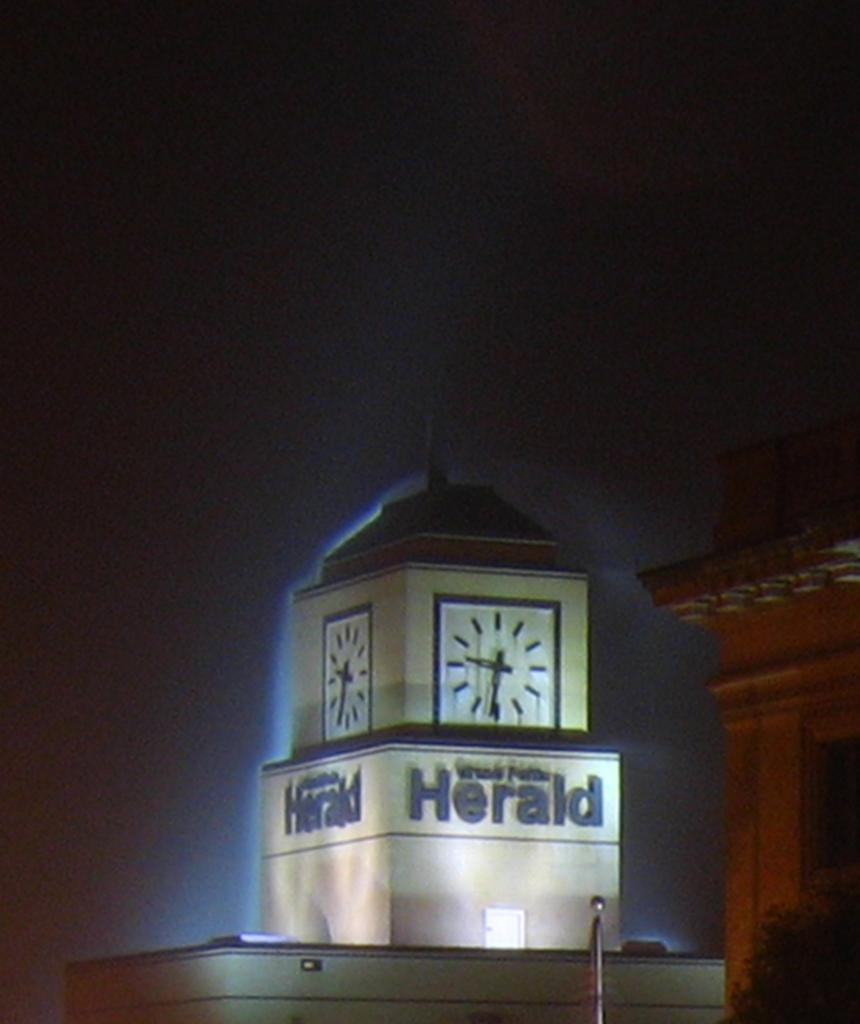Provide a one-sentence caption for the provided image. A clock tower says Herald in dark letters. 